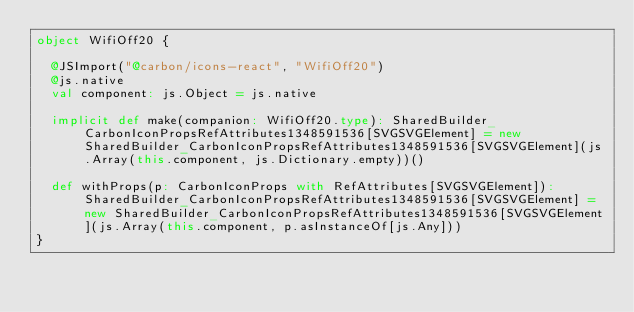<code> <loc_0><loc_0><loc_500><loc_500><_Scala_>object WifiOff20 {
  
  @JSImport("@carbon/icons-react", "WifiOff20")
  @js.native
  val component: js.Object = js.native
  
  implicit def make(companion: WifiOff20.type): SharedBuilder_CarbonIconPropsRefAttributes1348591536[SVGSVGElement] = new SharedBuilder_CarbonIconPropsRefAttributes1348591536[SVGSVGElement](js.Array(this.component, js.Dictionary.empty))()
  
  def withProps(p: CarbonIconProps with RefAttributes[SVGSVGElement]): SharedBuilder_CarbonIconPropsRefAttributes1348591536[SVGSVGElement] = new SharedBuilder_CarbonIconPropsRefAttributes1348591536[SVGSVGElement](js.Array(this.component, p.asInstanceOf[js.Any]))
}
</code> 